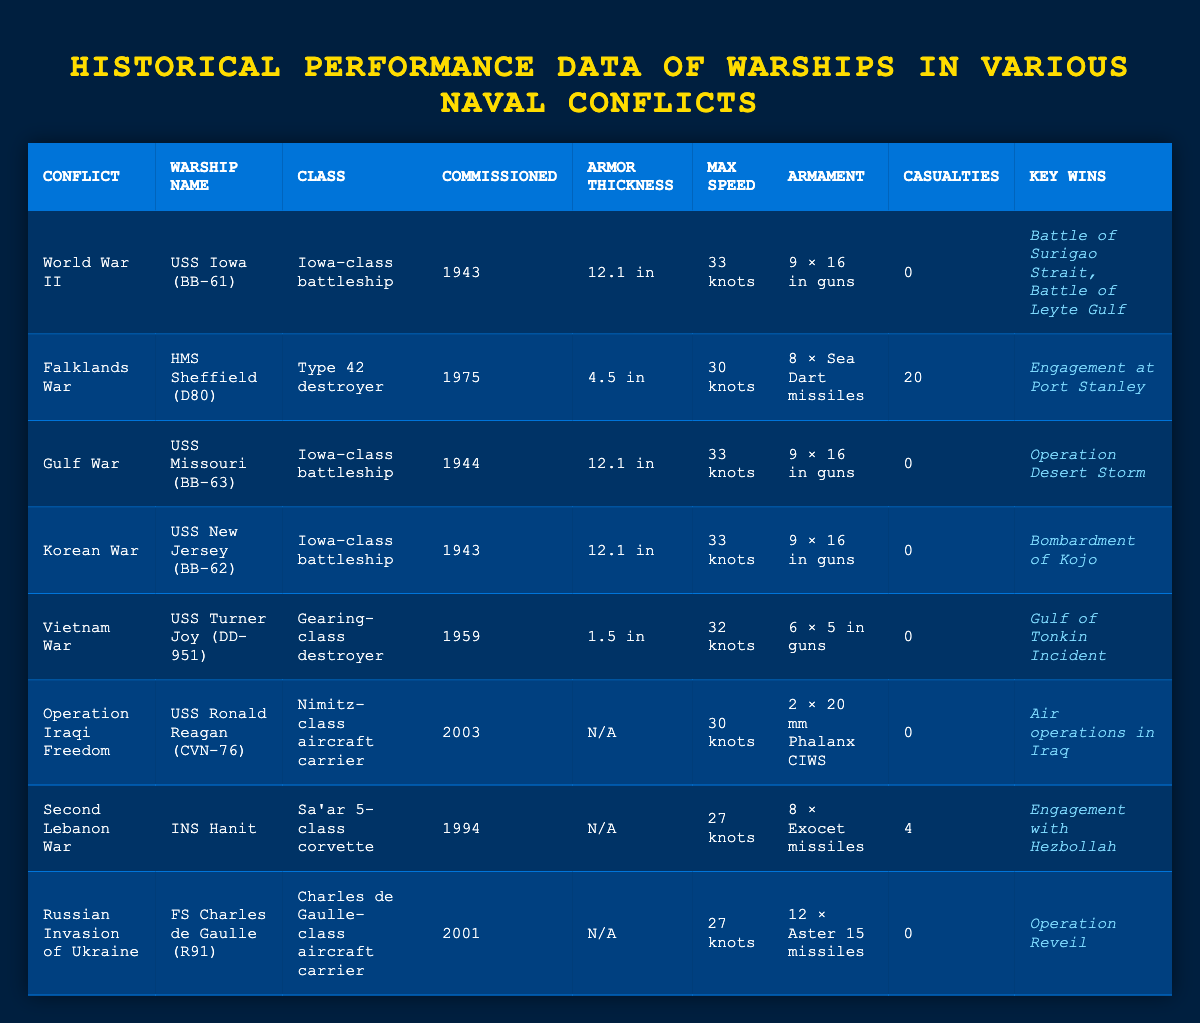What is the maximum speed of the USS Iowa (BB-61)? The table lists the USS Iowa (BB-61) under the World War II conflict, showing that its maximum speed is 33 knots.
Answer: 33 knots Which warship had the highest number of casualties in the table? By examining the casualties column, HMS Sheffield (D80) shows 20 casualties, which is more than any other warship listed.
Answer: HMS Sheffield (D80) How many Iowa-class battleships are mentioned in the table? The table includes three Iowa-class battleships: USS Iowa (BB-61), USS Missouri (BB-63), and USS New Jersey (BB-62). Thus, the total is three.
Answer: 3 What is the average armor thickness of the battleships listed? The Iowa-class battleships (USS Iowa, USS Missouri, USS New Jersey) each have an armor thickness of 12.1 inches, while USS Turner Joy has 1.5 inches. The average is calculated as follows: (12.1 + 12.1 + 12.1 + 1.5) / 4 = 33.8 / 4 = 8.45 inches.
Answer: 8.45 inches Did any of the warships in the table suffer casualties during their missions? Checking the casualties column reveals that HMS Sheffield (D80) and INS Hanit both have casualties recorded (20 and 4, respectively), indicating they did suffer casualties.
Answer: Yes What was the primary armament of USS Ronald Reagan (CVN-76)? The table indicates that the primary armament of USS Ronald Reagan (CVN-76) consists of 2 × 20 mm Phalanx CIWS.
Answer: 2 × 20 mm Phalanx CIWS Identify the conflict in which the USS Missouri (BB-63) participated. USS Missouri (BB-63) is listed under the Gulf War in the table.
Answer: Gulf War Which warship had the lowest maximum speed recorded in the table? Among the entries, the warship with the lowest maximum speed is INS Hanit at 27 knots.
Answer: INS Hanit Calculate the total number of key wins reported for all warships in the table. Examining the key wins for each warship yields: 2 for USS Iowa, 1 for HMS Sheffield, 1 for USS Missouri, 1 for USS New Jersey, 1 for USS Turner Joy, 1 for USS Ronald Reagan, 1 for INS Hanit, and 1 for FS Charles de Gaulle, totaling 9 key wins.
Answer: 9 How many conflicts do the listed warships cover in total? The table lists warships under the following conflicts: World War II, Falklands War, Gulf War, Korean War, Vietnam War, Operation Iraqi Freedom, Second Lebanon War, and Russian Invasion of Ukraine, which totals to 8 conflicts.
Answer: 8 